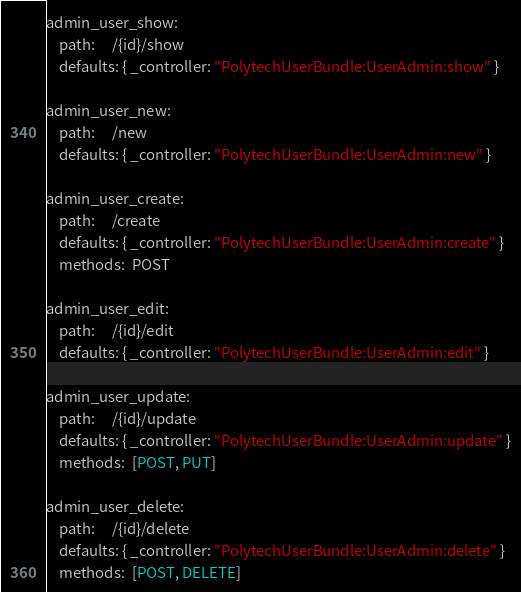<code> <loc_0><loc_0><loc_500><loc_500><_YAML_>
admin_user_show:
    path:     /{id}/show
    defaults: { _controller: "PolytechUserBundle:UserAdmin:show" }

admin_user_new:
    path:     /new
    defaults: { _controller: "PolytechUserBundle:UserAdmin:new" }

admin_user_create:
    path:     /create
    defaults: { _controller: "PolytechUserBundle:UserAdmin:create" }
    methods:  POST

admin_user_edit:
    path:     /{id}/edit
    defaults: { _controller: "PolytechUserBundle:UserAdmin:edit" }

admin_user_update:
    path:     /{id}/update
    defaults: { _controller: "PolytechUserBundle:UserAdmin:update" }
    methods:  [POST, PUT]

admin_user_delete:
    path:     /{id}/delete
    defaults: { _controller: "PolytechUserBundle:UserAdmin:delete" }
    methods:  [POST, DELETE]
</code> 